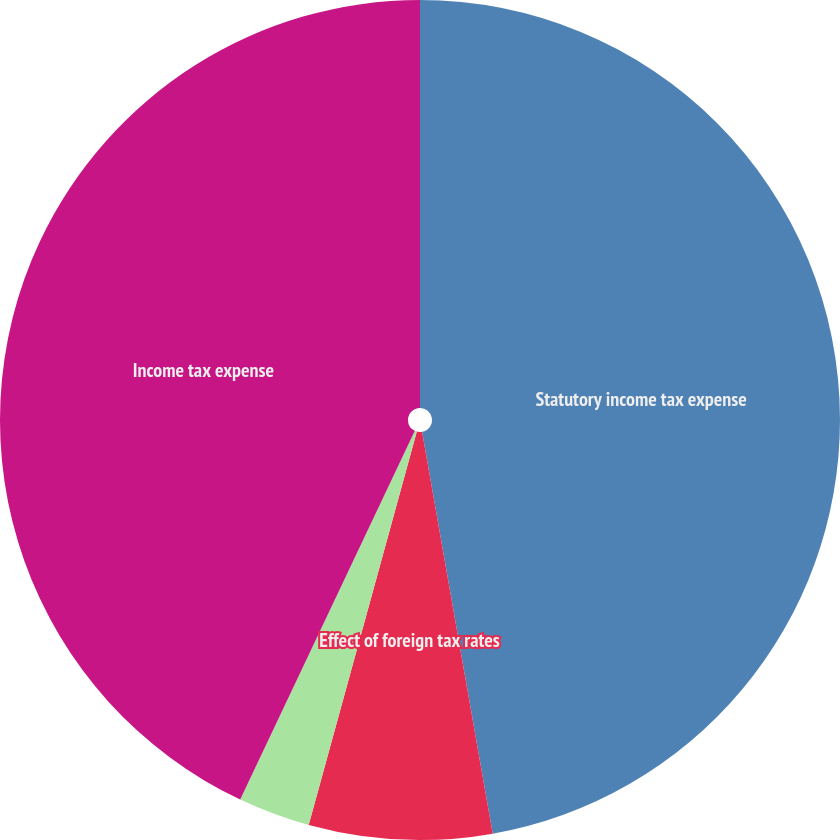Convert chart. <chart><loc_0><loc_0><loc_500><loc_500><pie_chart><fcel>Statutory income tax expense<fcel>Effect of foreign tax rates<fcel>State and local taxes (net of<fcel>Income tax expense<nl><fcel>47.23%<fcel>7.04%<fcel>2.77%<fcel>42.96%<nl></chart> 